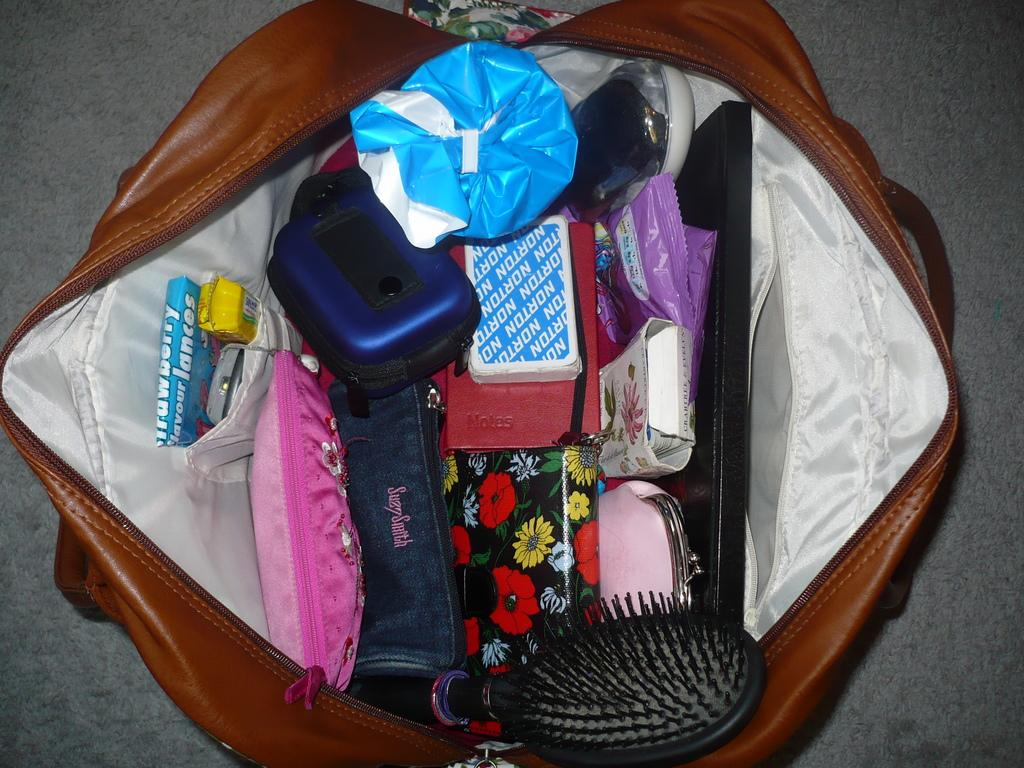What items can be found in the brown bag in the image? In the brown bag, there are toffees, a mobile, wallets, a box, gift wrap, a file, cards, and a comb. Can you describe the contents of the box in the brown bag? The facts provided do not give information about the contents of the box in the brown bag. What type of gift wrap is in the brown bag? The facts provided do not specify the type of gift wrap in the brown bag. What type of grain is being harvested in the background of the image? There is no indication of any grain or harvesting activity in the image. How does the wealth of the person holding the brown bag compare to the person next to them? The image does not provide any information about the wealth of the people in the image. 